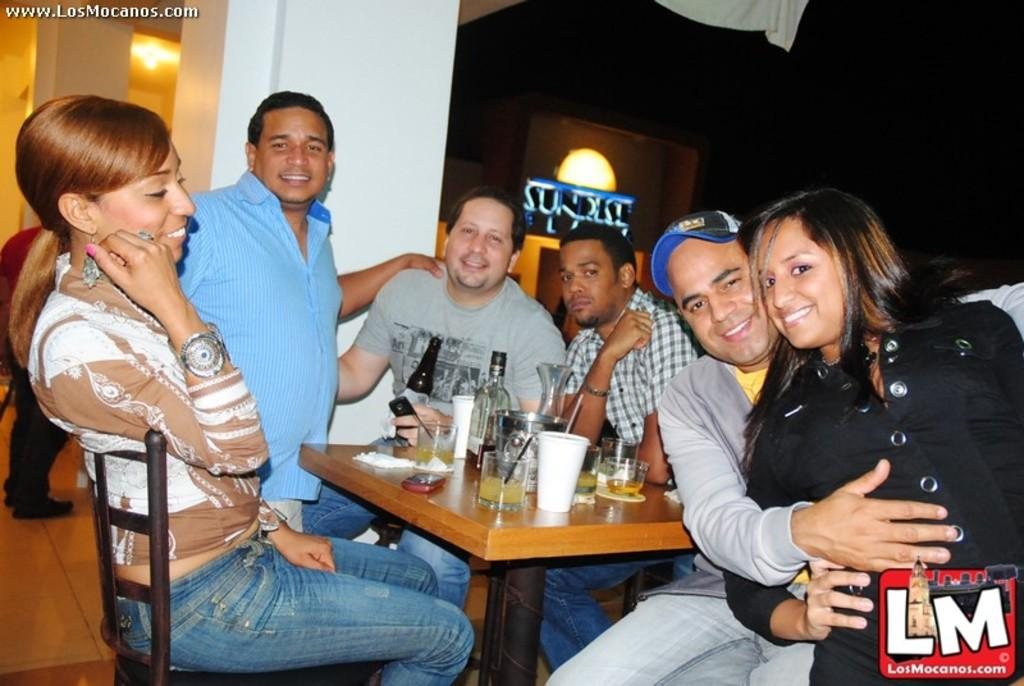What is happening in the image? There is a group of people in the image, and they are sitting around a table. How are the people in the image feeling? The people in the image are smiling, which suggests they are happy or enjoying themselves. What can be seen on the table in the image? There are objects on the table, but the specific items are not mentioned in the facts provided. What type of neck can be seen on the thing in the image? There is no thing or neck present in the image; it features a group of people sitting around a table and smiling. 